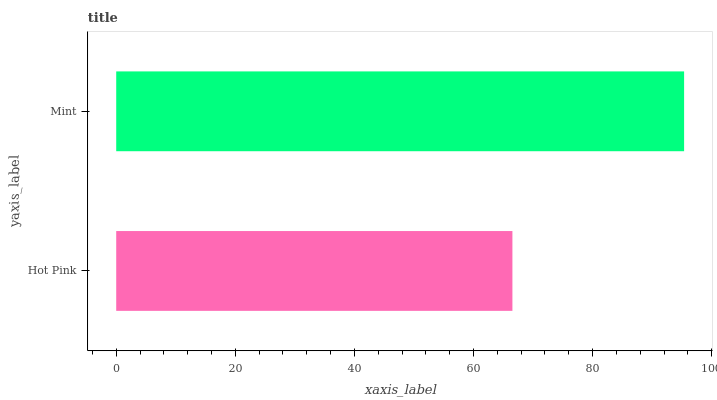Is Hot Pink the minimum?
Answer yes or no. Yes. Is Mint the maximum?
Answer yes or no. Yes. Is Mint the minimum?
Answer yes or no. No. Is Mint greater than Hot Pink?
Answer yes or no. Yes. Is Hot Pink less than Mint?
Answer yes or no. Yes. Is Hot Pink greater than Mint?
Answer yes or no. No. Is Mint less than Hot Pink?
Answer yes or no. No. Is Mint the high median?
Answer yes or no. Yes. Is Hot Pink the low median?
Answer yes or no. Yes. Is Hot Pink the high median?
Answer yes or no. No. Is Mint the low median?
Answer yes or no. No. 